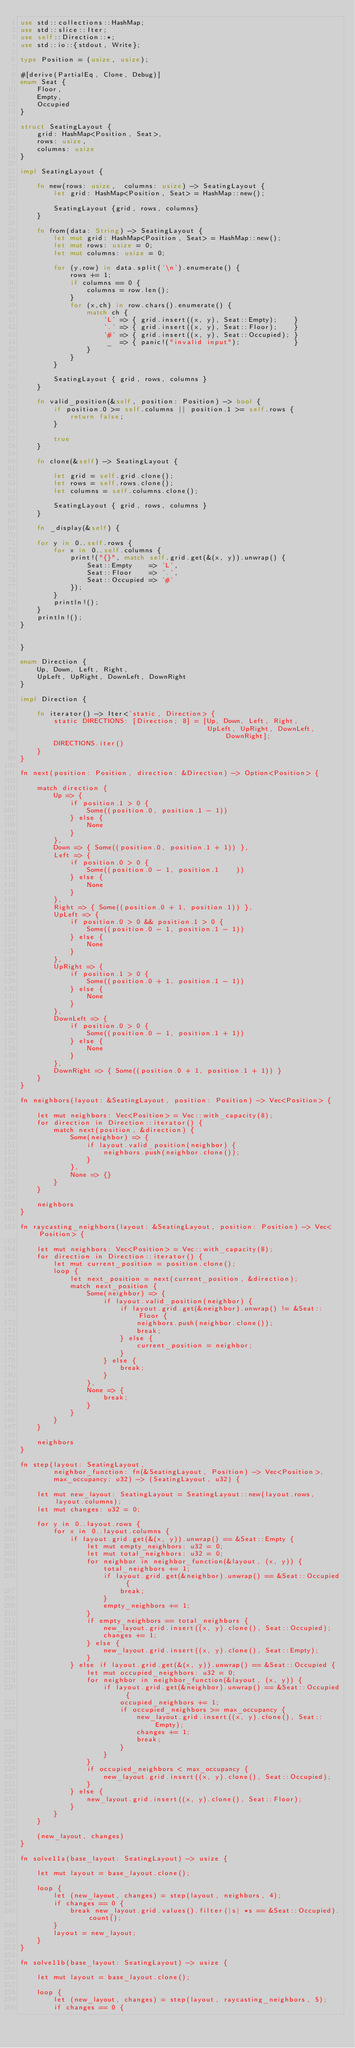Convert code to text. <code><loc_0><loc_0><loc_500><loc_500><_Rust_>use std::collections::HashMap;
use std::slice::Iter;
use self::Direction::*;
use std::io::{stdout, Write};

type Position = (usize, usize);

#[derive(PartialEq, Clone, Debug)]
enum Seat {
    Floor,
    Empty,
    Occupied
}

struct SeatingLayout {
    grid: HashMap<Position, Seat>,
    rows: usize,
    columns: usize
}

impl SeatingLayout {

    fn new(rows: usize,  columns: usize) -> SeatingLayout {
        let grid: HashMap<Position, Seat> = HashMap::new();

        SeatingLayout {grid, rows, columns}
    }

    fn from(data: String) -> SeatingLayout {
        let mut grid: HashMap<Position, Seat> = HashMap::new();
        let mut rows: usize = 0;
        let mut columns: usize = 0;

        for (y,row) in data.split('\n').enumerate() {
            rows += 1;
            if columns == 0 {
                columns = row.len();
            }
            for (x,ch) in row.chars().enumerate() {
                match ch {
                    'L' => { grid.insert((x, y), Seat::Empty);    }
                    '.' => { grid.insert((x, y), Seat::Floor);    }
                    '#' => { grid.insert((x, y), Seat::Occupied); }
                     _  => { panic!("invalid input");             }
                }
            }
        }

        SeatingLayout { grid, rows, columns }
    }

    fn valid_position(&self, position: Position) -> bool {
        if position.0 >= self.columns || position.1 >= self.rows {
            return false;
        }

        true
    }

    fn clone(&self) -> SeatingLayout {

        let grid = self.grid.clone();
        let rows = self.rows.clone();
        let columns = self.columns.clone();

        SeatingLayout { grid, rows, columns }
    }

    fn _display(&self) {

    for y in 0..self.rows {
        for x in 0..self.columns {
            print!("{}", match self.grid.get(&(x, y)).unwrap() {
                Seat::Empty    => 'L',
                Seat::Floor    => '.',
                Seat::Occupied => '#'
            });
        }
        println!();
    }
    println!();
}


}

enum Direction {
    Up, Down, Left, Right,
    UpLeft, UpRight, DownLeft, DownRight
}

impl Direction {

    fn iterator() -> Iter<'static, Direction> {
        static DIRECTIONS: [Direction; 8] = [Up, Down, Left, Right,
                                             UpLeft, UpRight, DownLeft, DownRight];
        DIRECTIONS.iter()
    }
}

fn next(position: Position, direction: &Direction) -> Option<Position> {

    match direction {
        Up => {
            if position.1 > 0 {
                Some((position.0, position.1 - 1))
            } else {
                None
            }
        },
        Down => { Some((position.0, position.1 + 1)) },
        Left => {
            if position.0 > 0 {
                Some((position.0 - 1, position.1    ))
            } else {
                None
            }
        },
        Right => { Some((position.0 + 1, position.1)) },
        UpLeft => {
            if position.0 > 0 && position.1 > 0 {
                Some((position.0 - 1, position.1 - 1))
            } else {
                None
            }
        },
        UpRight => {
            if position.1 > 0 {
                Some((position.0 + 1, position.1 - 1))
            } else {
                None
            }
        },
        DownLeft => {
            if position.0 > 0 {
                Some((position.0 - 1, position.1 + 1))
            } else {
                None
            }
        },
        DownRight => { Some((position.0 + 1, position.1 + 1)) }
    }
}

fn neighbors(layout: &SeatingLayout, position: Position) -> Vec<Position> {

    let mut neighbors: Vec<Position> = Vec::with_capacity(8);
    for direction in Direction::iterator() {
        match next(position, &direction) {
            Some(neighbor) => {
                if layout.valid_position(neighbor) {
                    neighbors.push(neighbor.clone());
                }
            },
            None => {}
        }
    }

    neighbors
}

fn raycasting_neighbors(layout: &SeatingLayout, position: Position) -> Vec<Position> {

    let mut neighbors: Vec<Position> = Vec::with_capacity(8);
    for direction in Direction::iterator() {
        let mut current_position = position.clone();
        loop {
            let next_position = next(current_position, &direction);
            match next_position {
                Some(neighbor) => {
                    if layout.valid_position(neighbor) {
                        if layout.grid.get(&neighbor).unwrap() != &Seat::Floor {
                            neighbors.push(neighbor.clone());
                            break;
                        } else {
                            current_position = neighbor;
                        }
                    } else {
                        break;
                    }
                },
                None => {
                    break;
                }
            }
        }
    }

    neighbors
}

fn step(layout: SeatingLayout,
        neighbor_function: fn(&SeatingLayout, Position) -> Vec<Position>,
        max_occupancy: u32) -> (SeatingLayout, u32) {

    let mut new_layout: SeatingLayout = SeatingLayout::new(layout.rows, layout.columns);
    let mut changes: u32 = 0;

    for y in 0..layout.rows {
        for x in 0..layout.columns {
            if layout.grid.get(&(x, y)).unwrap() == &Seat::Empty {
                let mut empty_neighbors: u32 = 0;
                let mut total_neighbors: u32 = 0;
                for neighbor in neighbor_function(&layout, (x, y)) {
                    total_neighbors += 1;
                    if layout.grid.get(&neighbor).unwrap() == &Seat::Occupied {
                        break;
                    }
                    empty_neighbors += 1;
                }
                if empty_neighbors == total_neighbors {
                    new_layout.grid.insert((x, y).clone(), Seat::Occupied);
                    changes += 1;
                } else {
                    new_layout.grid.insert((x, y).clone(), Seat::Empty);
                }
            } else if layout.grid.get(&(x, y)).unwrap() == &Seat::Occupied {
                let mut occupied_neighbors: u32 = 0;
                for neighbor in neighbor_function(&layout, (x, y)) {
                    if layout.grid.get(&neighbor).unwrap() == &Seat::Occupied {
                        occupied_neighbors += 1;
                        if occupied_neighbors >= max_occupancy {
                            new_layout.grid.insert((x, y).clone(), Seat::Empty);
                            changes += 1;
                            break;
                        }
                    }
                }
                if occupied_neighbors < max_occupancy {
                    new_layout.grid.insert((x, y).clone(), Seat::Occupied);
                }
            } else {
                new_layout.grid.insert((x, y).clone(), Seat::Floor);
            }
        }
    }

    (new_layout, changes)
}

fn solve11a(base_layout: SeatingLayout) -> usize {

    let mut layout = base_layout.clone();

    loop {
        let (new_layout, changes) = step(layout, neighbors, 4);
        if changes == 0 {
            break new_layout.grid.values().filter(|s| *s == &Seat::Occupied).count();
        }
        layout = new_layout;
    }
}

fn solve11b(base_layout: SeatingLayout) -> usize {

    let mut layout = base_layout.clone();

    loop {
        let (new_layout, changes) = step(layout, raycasting_neighbors, 5);
        if changes == 0 {</code> 